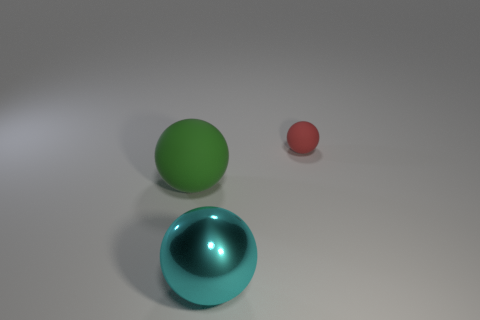Add 3 small red objects. How many objects exist? 6 Add 1 big shiny spheres. How many big shiny spheres exist? 2 Subtract 0 blue balls. How many objects are left? 3 Subtract all tiny blue objects. Subtract all big green things. How many objects are left? 2 Add 2 large matte balls. How many large matte balls are left? 3 